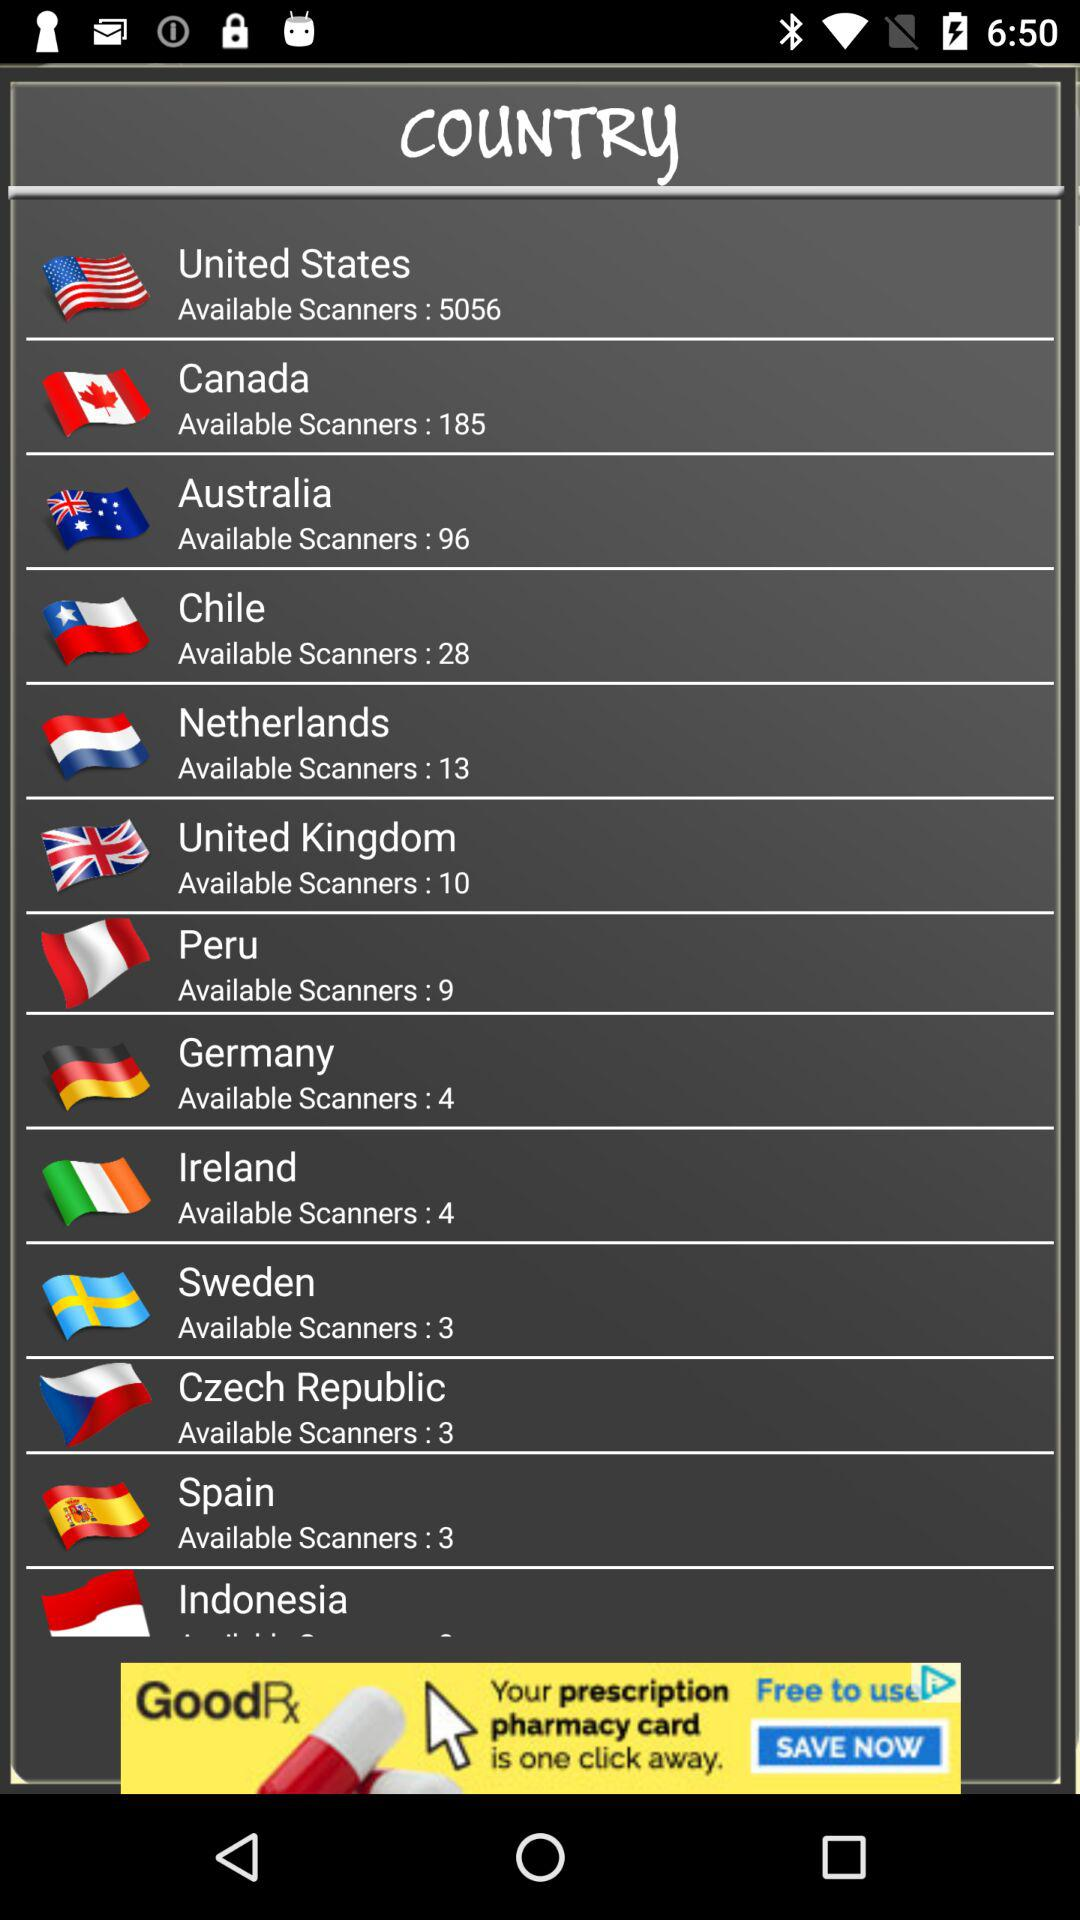Which country has the most available scanners?
Answer the question using a single word or phrase. United States 